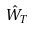<formula> <loc_0><loc_0><loc_500><loc_500>\hat { W } _ { T }</formula> 